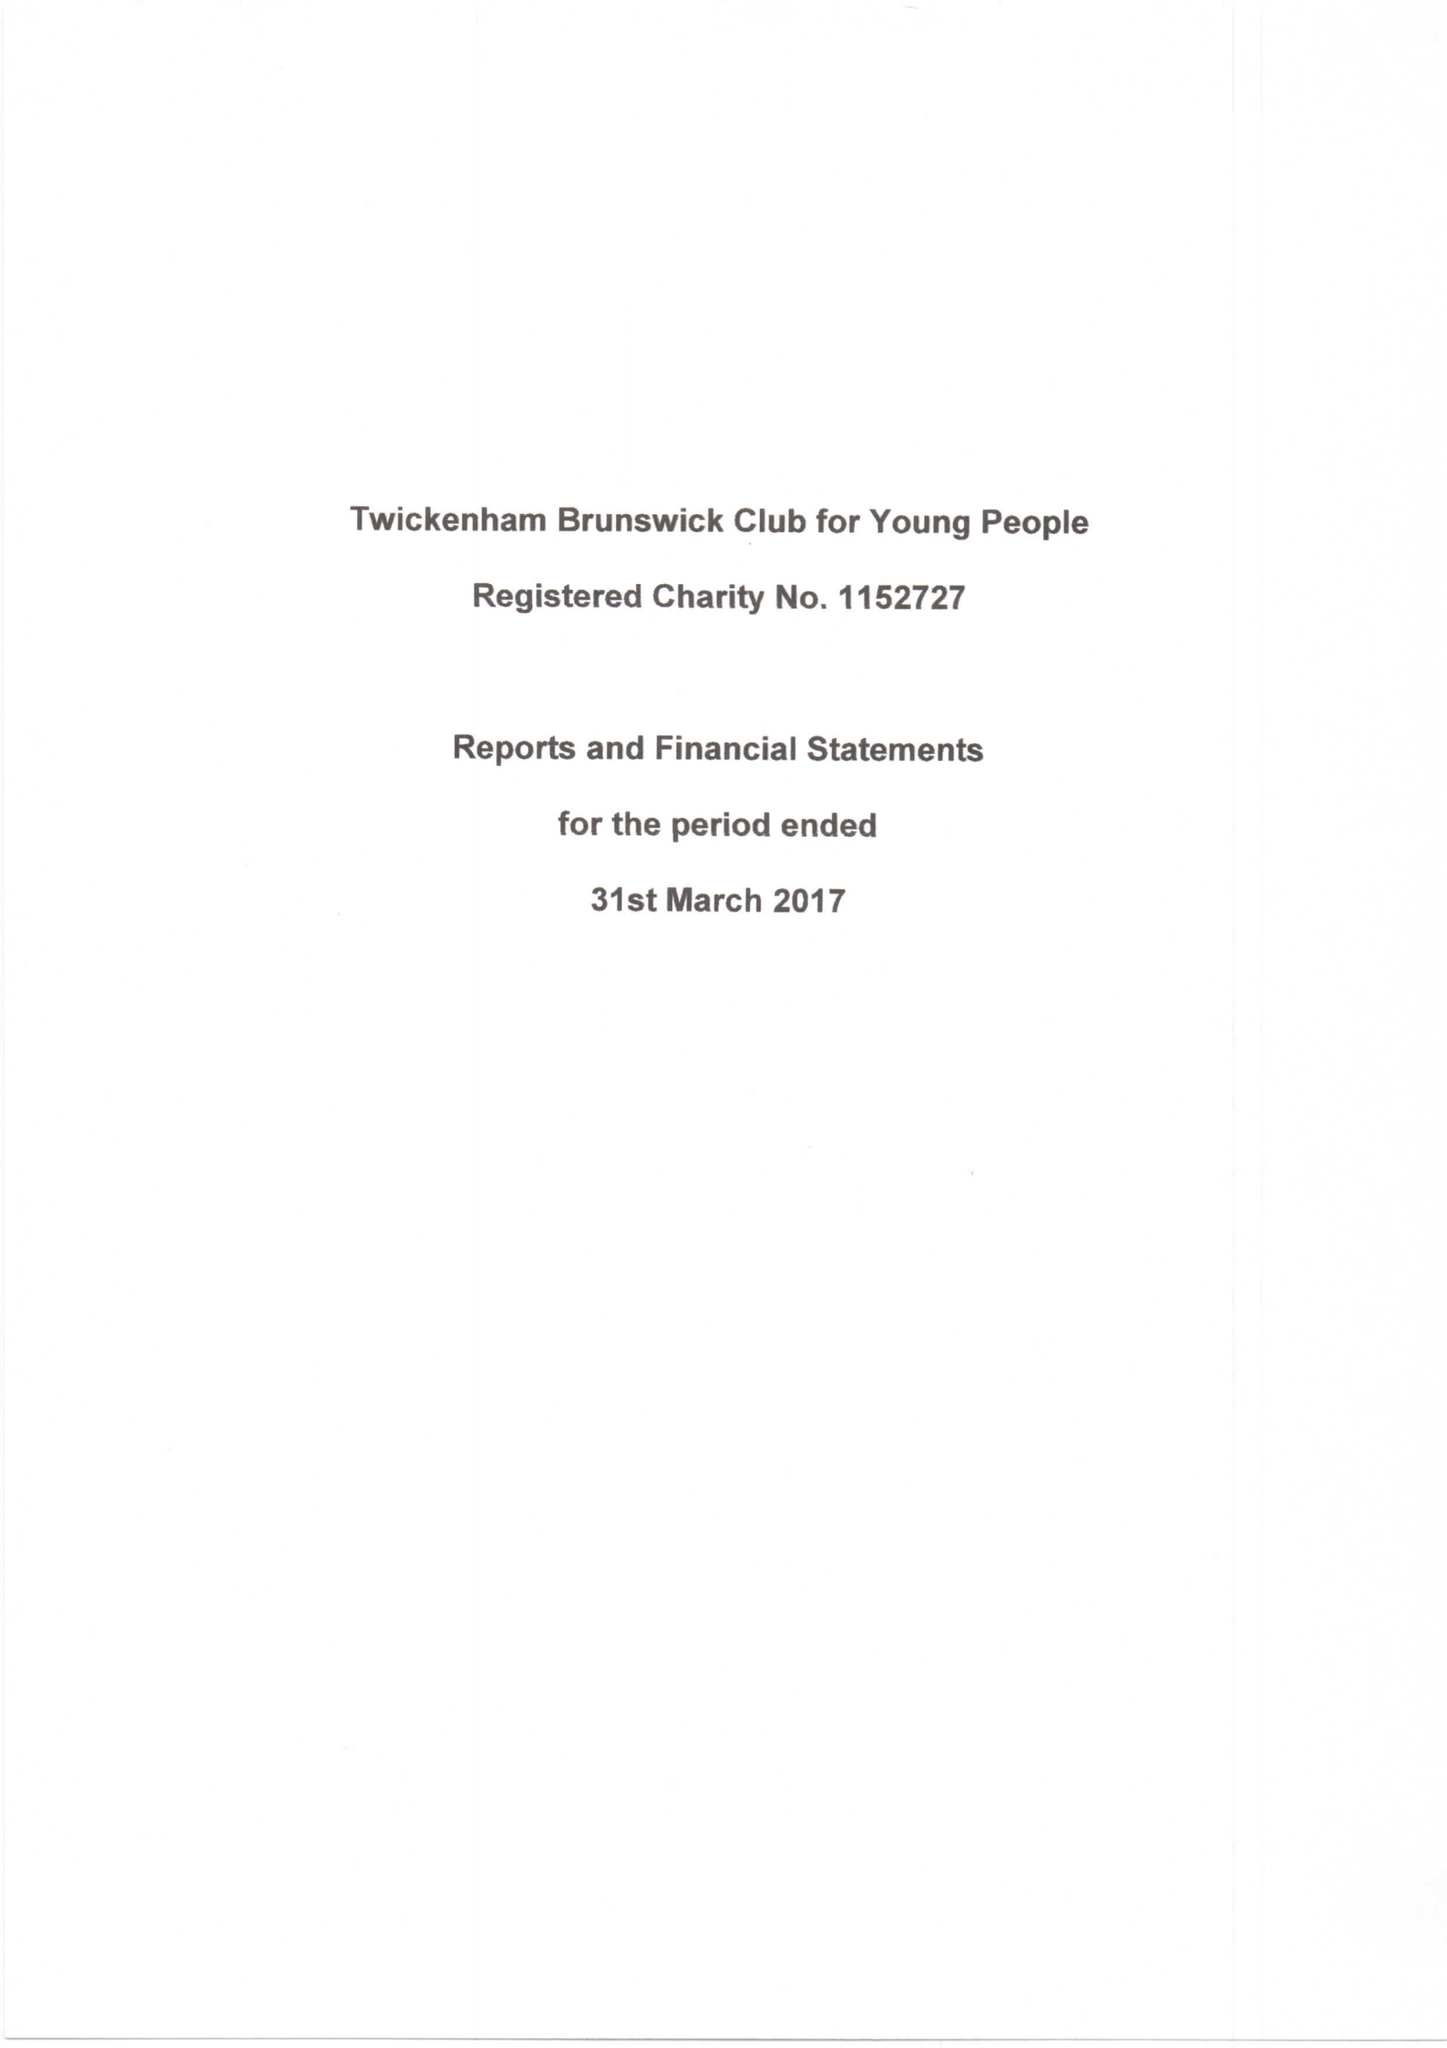What is the value for the charity_number?
Answer the question using a single word or phrase. 1152727 